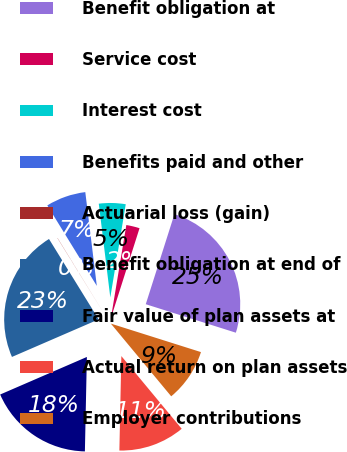Convert chart to OTSL. <chart><loc_0><loc_0><loc_500><loc_500><pie_chart><fcel>Benefit obligation at<fcel>Service cost<fcel>Interest cost<fcel>Benefits paid and other<fcel>Actuarial loss (gain)<fcel>Benefit obligation at end of<fcel>Fair value of plan assets at<fcel>Actual return on plan assets<fcel>Employer contributions<nl><fcel>24.97%<fcel>2.29%<fcel>4.56%<fcel>6.83%<fcel>0.03%<fcel>22.7%<fcel>18.16%<fcel>11.36%<fcel>9.1%<nl></chart> 